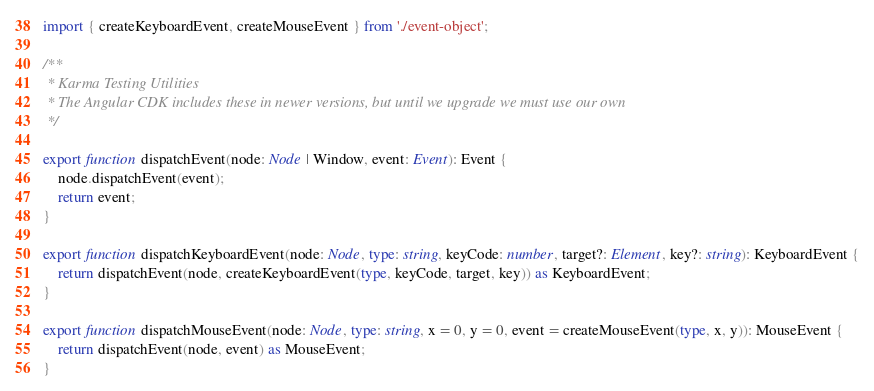<code> <loc_0><loc_0><loc_500><loc_500><_TypeScript_>import { createKeyboardEvent, createMouseEvent } from './event-object';

/**
 * Karma Testing Utilities
 * The Angular CDK includes these in newer versions, but until we upgrade we must use our own
 */

export function dispatchEvent(node: Node | Window, event: Event): Event {
    node.dispatchEvent(event);
    return event;
}

export function dispatchKeyboardEvent(node: Node, type: string, keyCode: number, target?: Element, key?: string): KeyboardEvent {
    return dispatchEvent(node, createKeyboardEvent(type, keyCode, target, key)) as KeyboardEvent;
}

export function dispatchMouseEvent(node: Node, type: string, x = 0, y = 0, event = createMouseEvent(type, x, y)): MouseEvent {
    return dispatchEvent(node, event) as MouseEvent;
}</code> 